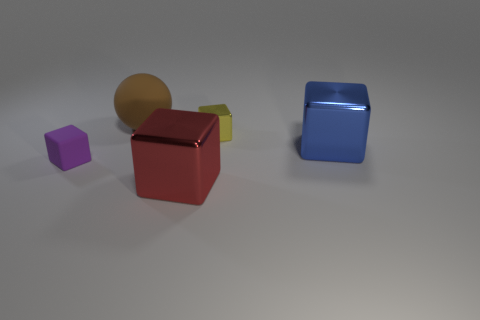Are there any shadows indicating a light source? Yes, there are shadows cast behind each object, indicating that there is a light source in the front left area of the scene, as seen from the viewer's perspective. Does the direction of the shadows help determine what time of day it might be? This scene appears to be an indoor studio set-up rather than a natural environment, so the shadows are not helpful in determining the time of day. Instead, they reveal the placement of artificial lighting within the space. 